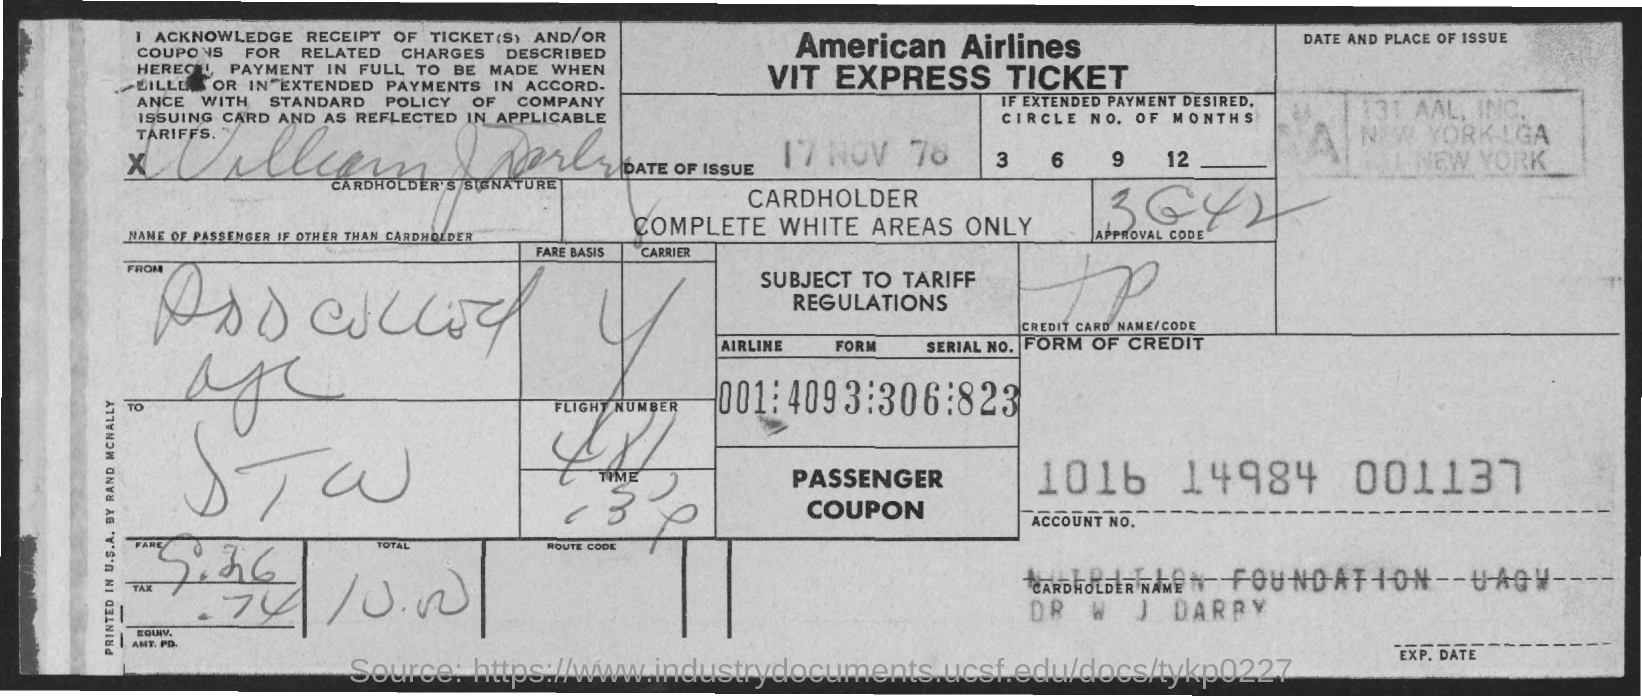Which airlines is mentioned?
Your answer should be compact. American Airlines. What is the date of issue?
Give a very brief answer. 17 NOV 78. What is the Account Number?
Your response must be concise. 1016 14984 001137. 